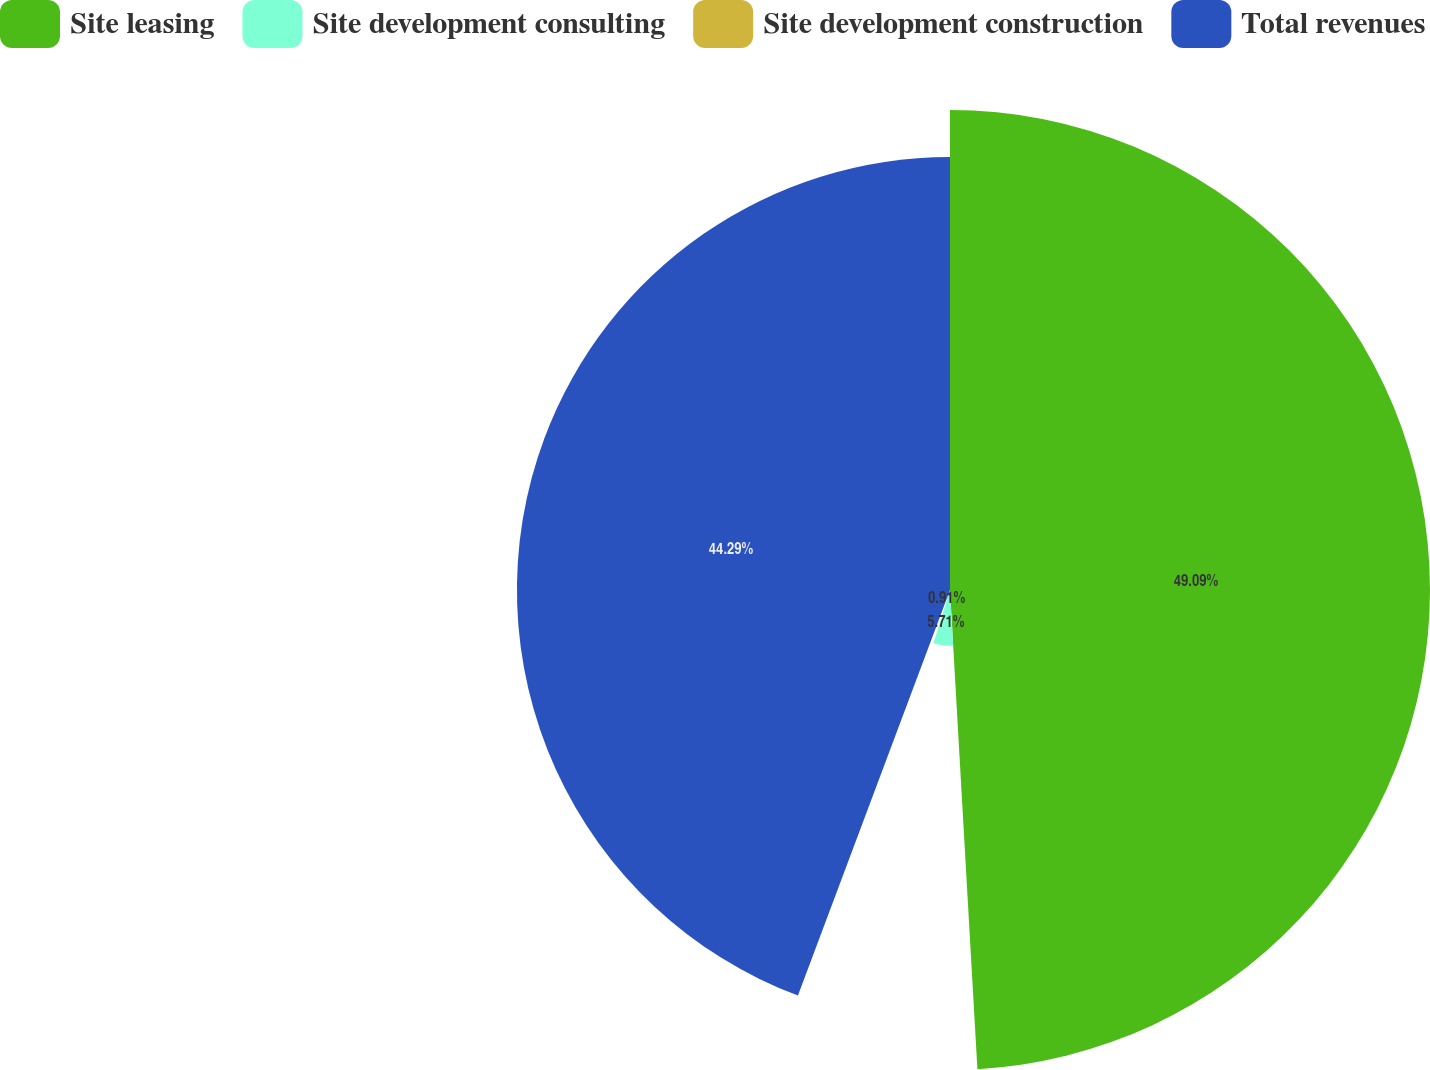<chart> <loc_0><loc_0><loc_500><loc_500><pie_chart><fcel>Site leasing<fcel>Site development consulting<fcel>Site development construction<fcel>Total revenues<nl><fcel>49.09%<fcel>5.71%<fcel>0.91%<fcel>44.29%<nl></chart> 